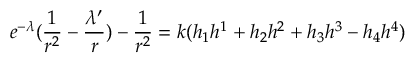<formula> <loc_0><loc_0><loc_500><loc_500>e ^ { - { \lambda } } ( \frac { 1 } { r ^ { 2 } } - \frac { { \lambda } ^ { \prime } } { r } ) - \frac { 1 } { r ^ { 2 } } = k ( h _ { 1 } h ^ { 1 } + h _ { 2 } h ^ { 2 } + h _ { 3 } h ^ { 3 } - h _ { 4 } h ^ { 4 } )</formula> 